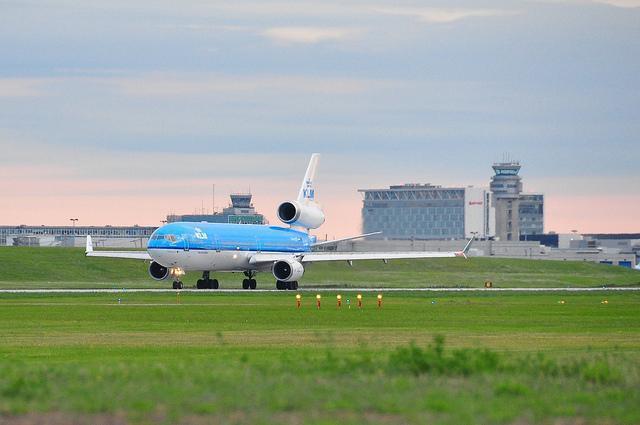How many people are sitting?
Give a very brief answer. 0. 